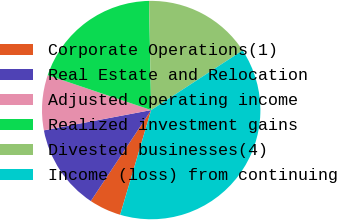Convert chart. <chart><loc_0><loc_0><loc_500><loc_500><pie_chart><fcel>Corporate Operations(1)<fcel>Real Estate and Relocation<fcel>Adjusted operating income<fcel>Realized investment gains<fcel>Divested businesses(4)<fcel>Income (loss) from continuing<nl><fcel>4.74%<fcel>12.7%<fcel>8.15%<fcel>19.51%<fcel>16.11%<fcel>38.79%<nl></chart> 